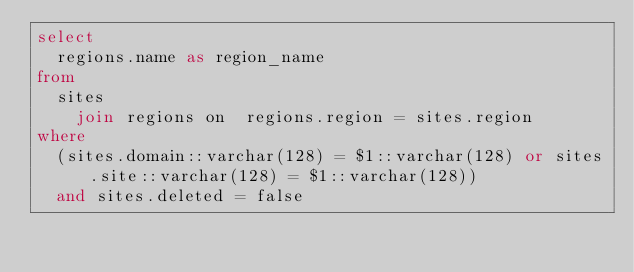<code> <loc_0><loc_0><loc_500><loc_500><_SQL_>select 
	regions.name as region_name
from
	sites 
		join regions on  regions.region = sites.region 
where
	(sites.domain::varchar(128) = $1::varchar(128) or sites.site::varchar(128) = $1::varchar(128)) 
	and sites.deleted = false </code> 